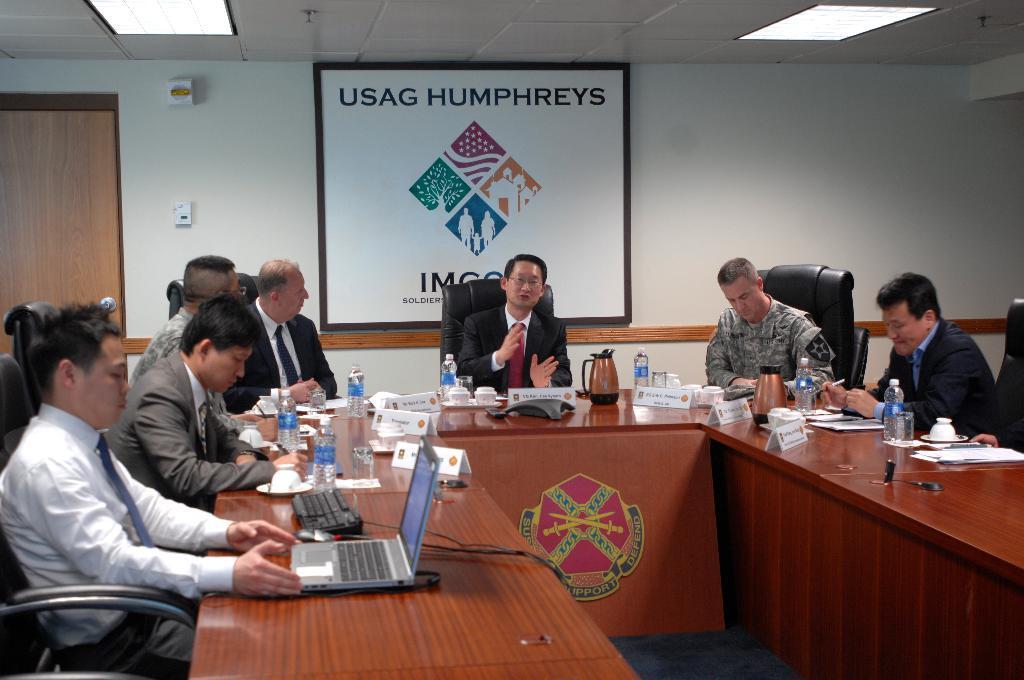Please provide a concise description of this image. It is a room where group of people are sitting on the chairs in front of the desk, where bottles ,papers are present on it, behind a person their is a wall and a picture having some text on it, behind them there is a door. 